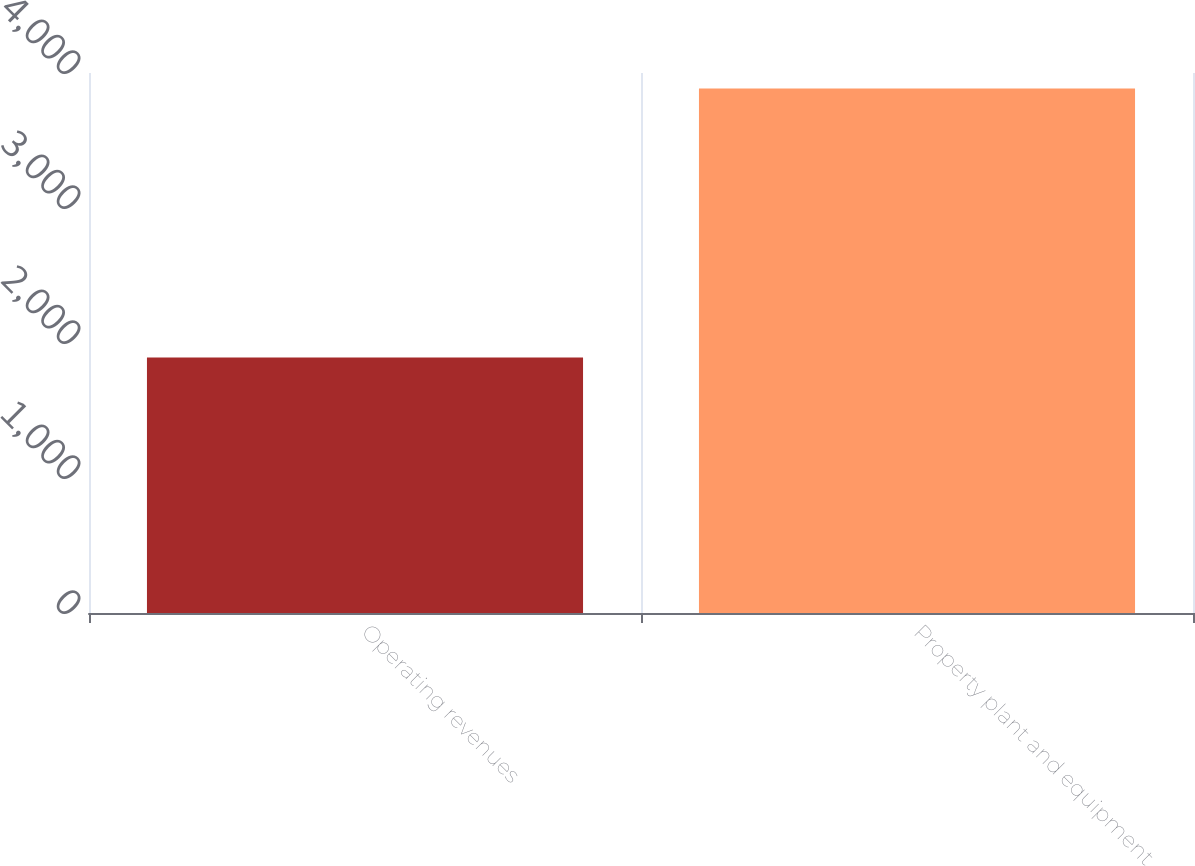<chart> <loc_0><loc_0><loc_500><loc_500><bar_chart><fcel>Operating revenues<fcel>Property plant and equipment<nl><fcel>1893<fcel>3885<nl></chart> 